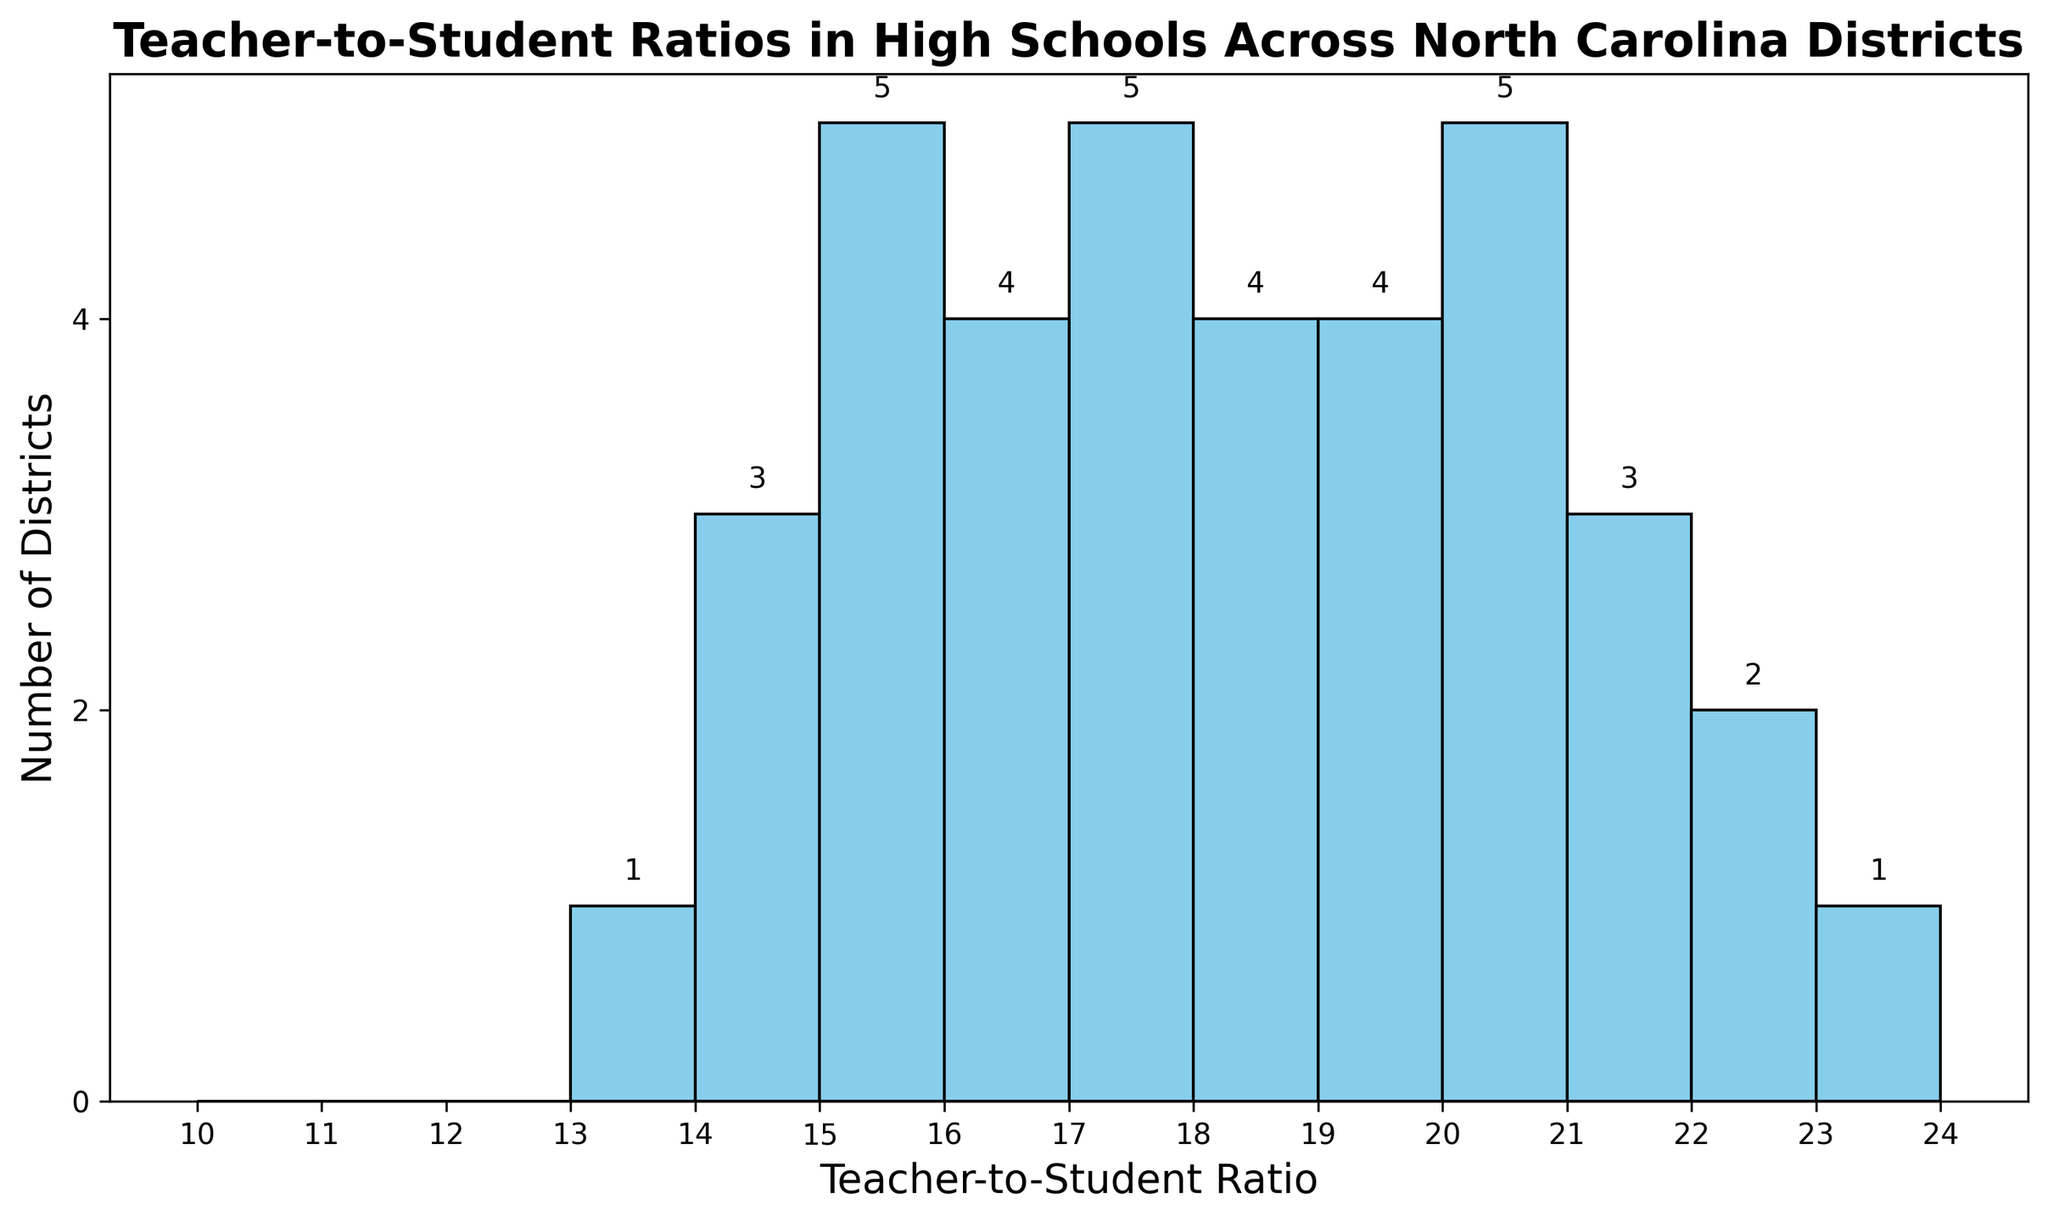What's the most common Teacher-to-Student ratio in the districts? The highest frequency bar represents the most common ratio. From the histogram, the Teacher-to-Student ratio of 17 appears most frequently as its bar is tallest.
Answer: 17 How many districts have a Teacher-to-Student ratio of 15? Identify the bar corresponding to the ratio of 15 and note the height, which represents the number of districts. The bar reaches up to 5, indicating 5 districts.
Answer: 5 What is the range of Teacher-to-Student ratios shown in the histogram? The range is found by subtracting the smallest ratio (13) from the largest ratio (23) displayed on the x-axis of the histogram.
Answer: 10 Are there more districts with a Teacher-to-Student ratio of 18 or 20? Compare the heights of the bars at 18 and 20. The bar at 18 is taller, indicating more districts at this ratio.
Answer: 18 How many ratios are represented by a single district only? Identify bars with a height of 1. Ratios 13 and 23 each have bars of height 1. Therefore, there are 2 such ratios.
Answer: 2 What is the average Teacher-to-Student ratio across all districts? Sum all ratios from the data and divide by the total number of districts (37). \[ (13+14+14+14+15+15+15+15+15+15+16+16+16+16+17+17+17+17+17+18+18+18+18+19+19+19+19+20+20+20+20+21+21+21+22+22+23) \] Sum = 644, Average = 644 / 37 ≈ 17.4
Answer: 17.4 How many districts fall within the ratio range of 15 to 18 (inclusive)? Count the bars from ratios 15 through 18. The bars at 15 = 5, 16 = 4, 17 = 6, 18 = 5. Summing them gives 5 + 4 + 6 + 5 = 20 districts.
Answer: 20 